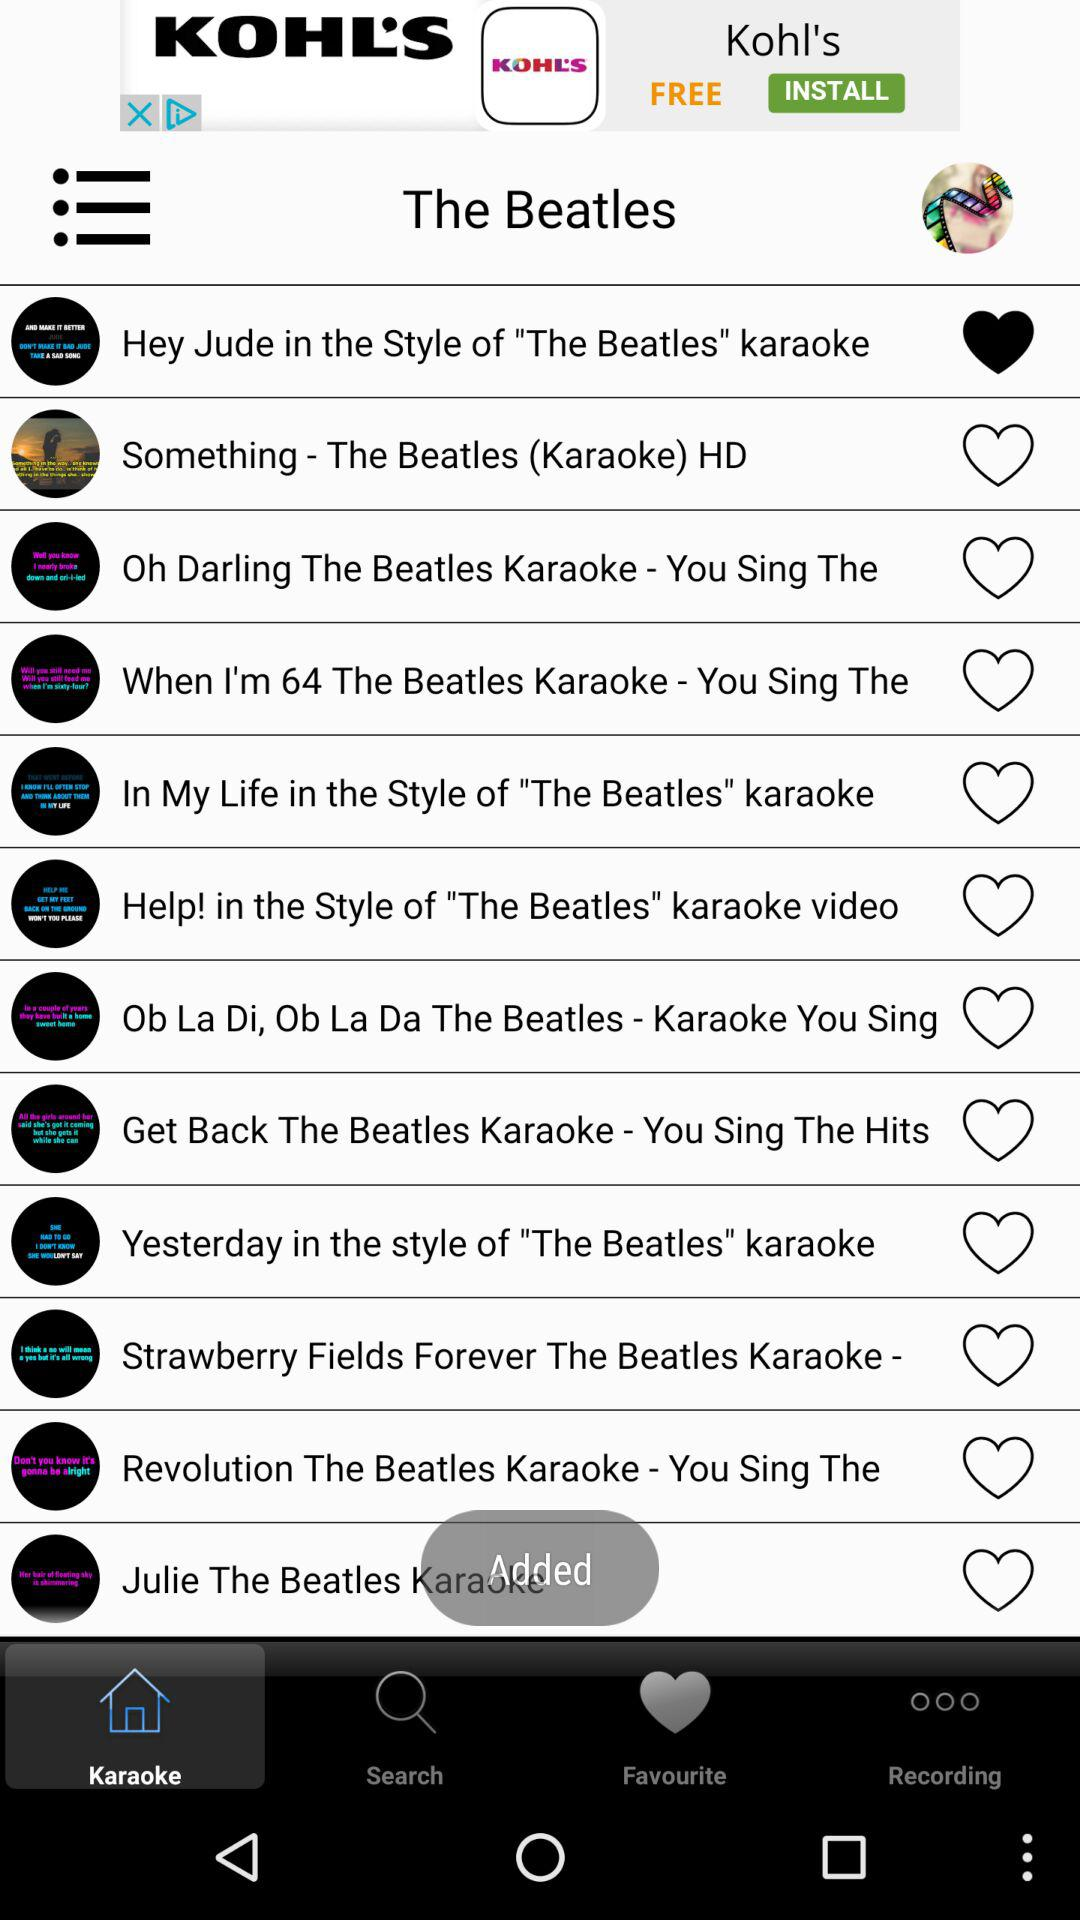Which tab am I now on? You are now on the "Karaoke" tab. 